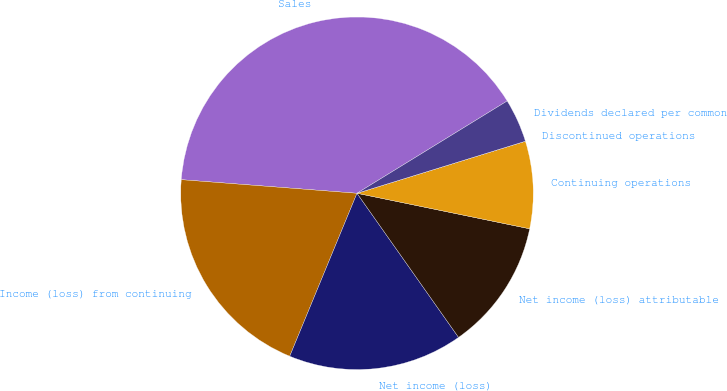Convert chart. <chart><loc_0><loc_0><loc_500><loc_500><pie_chart><fcel>Sales<fcel>Income (loss) from continuing<fcel>Net income (loss)<fcel>Net income (loss) attributable<fcel>Continuing operations<fcel>Discontinued operations<fcel>Dividends declared per common<nl><fcel>40.0%<fcel>20.0%<fcel>16.0%<fcel>12.0%<fcel>8.0%<fcel>0.0%<fcel>4.0%<nl></chart> 